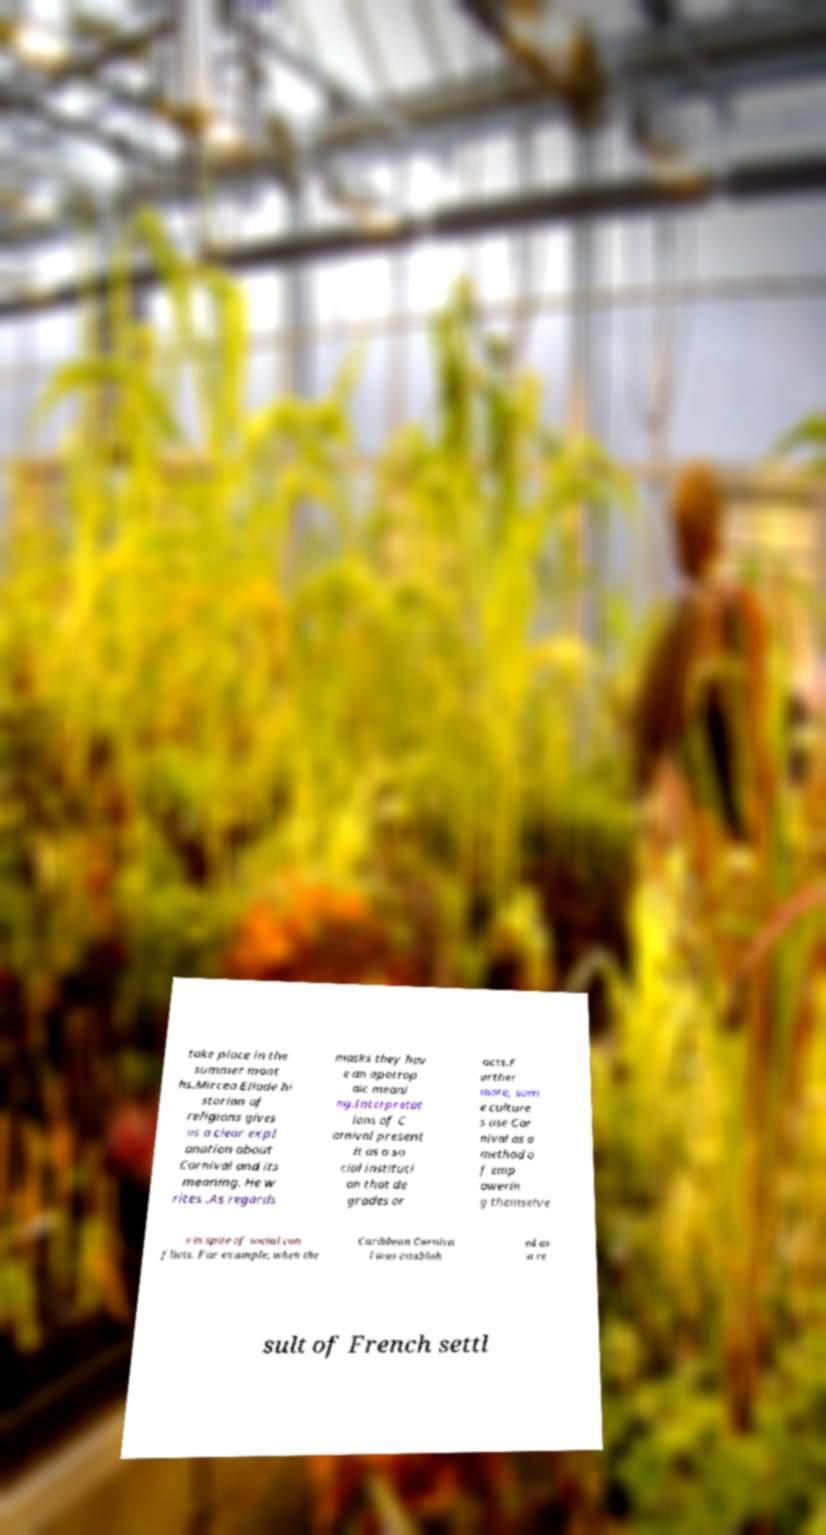Can you read and provide the text displayed in the image?This photo seems to have some interesting text. Can you extract and type it out for me? take place in the summer mont hs.Mircea Eliade hi storian of religions gives us a clear expl anation about Carnival and its meaning. He w rites .As regards masks they hav e an apotrop aic meani ng.Interpretat ions of C arnival present it as a so cial instituti on that de grades or acts.F urther more, som e culture s use Car nival as a method o f emp owerin g themselve s in spite of social con flicts. For example, when the Caribbean Carniva l was establish ed as a re sult of French settl 